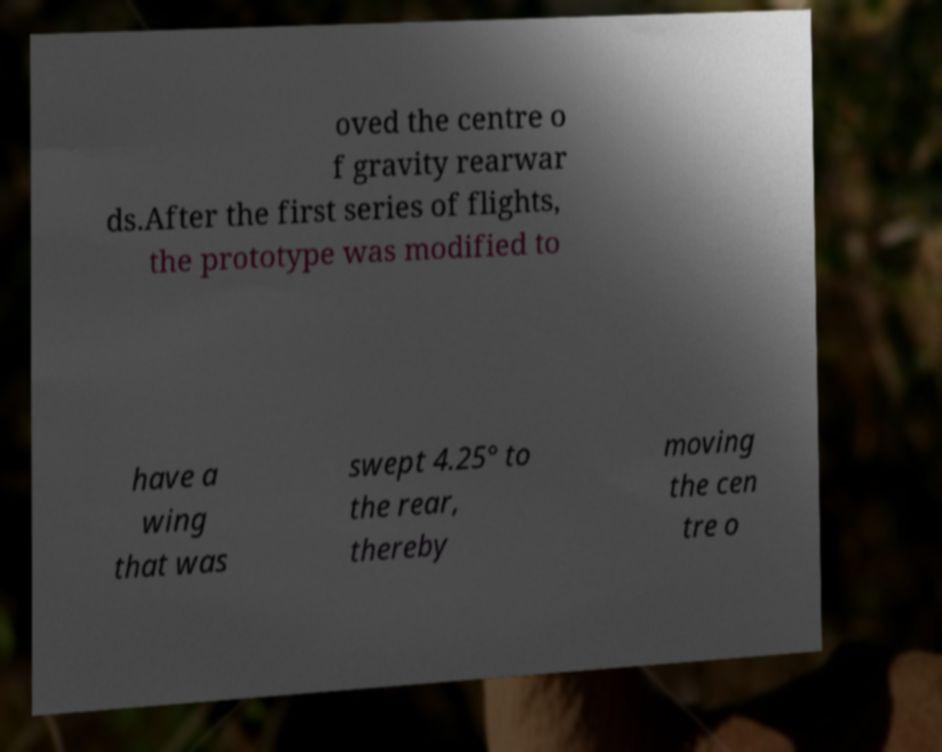Could you extract and type out the text from this image? oved the centre o f gravity rearwar ds.After the first series of flights, the prototype was modified to have a wing that was swept 4.25° to the rear, thereby moving the cen tre o 